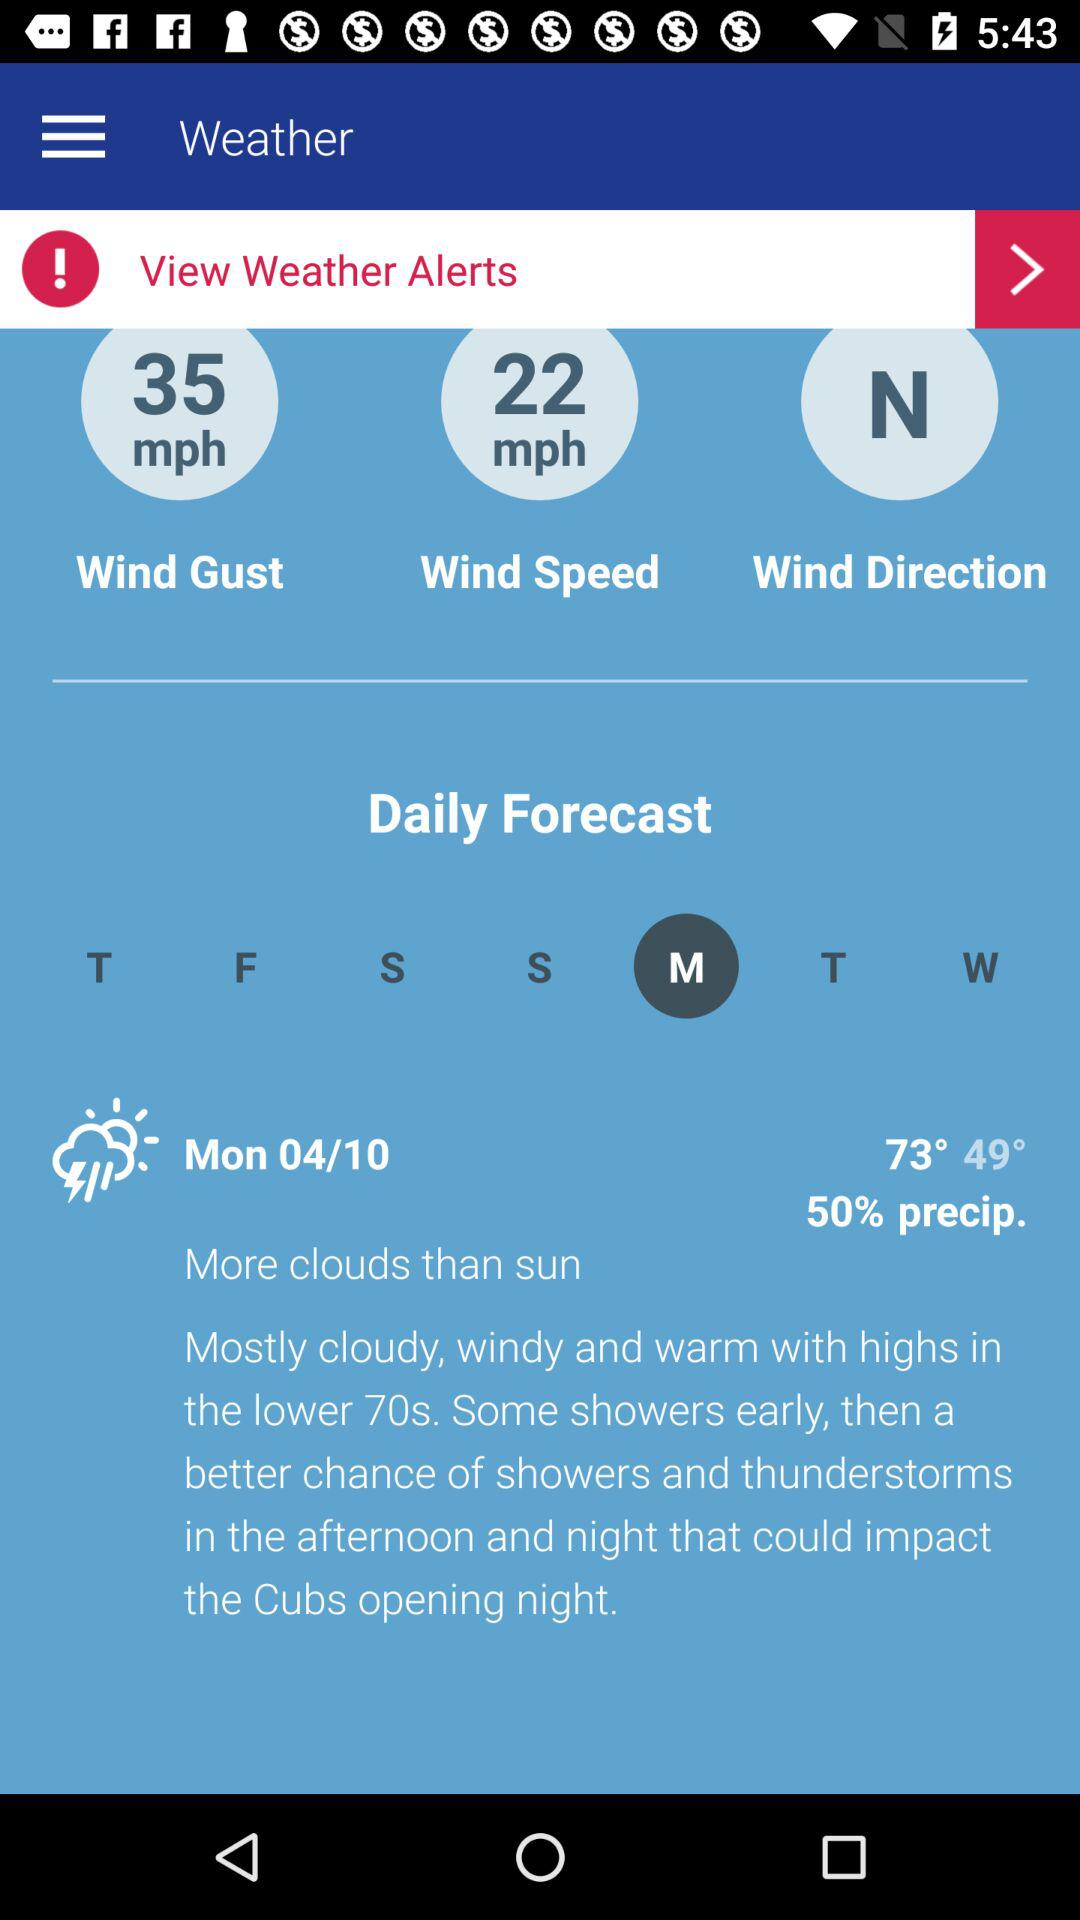What is the percentage of precipitation? The precipitation is 50%. 